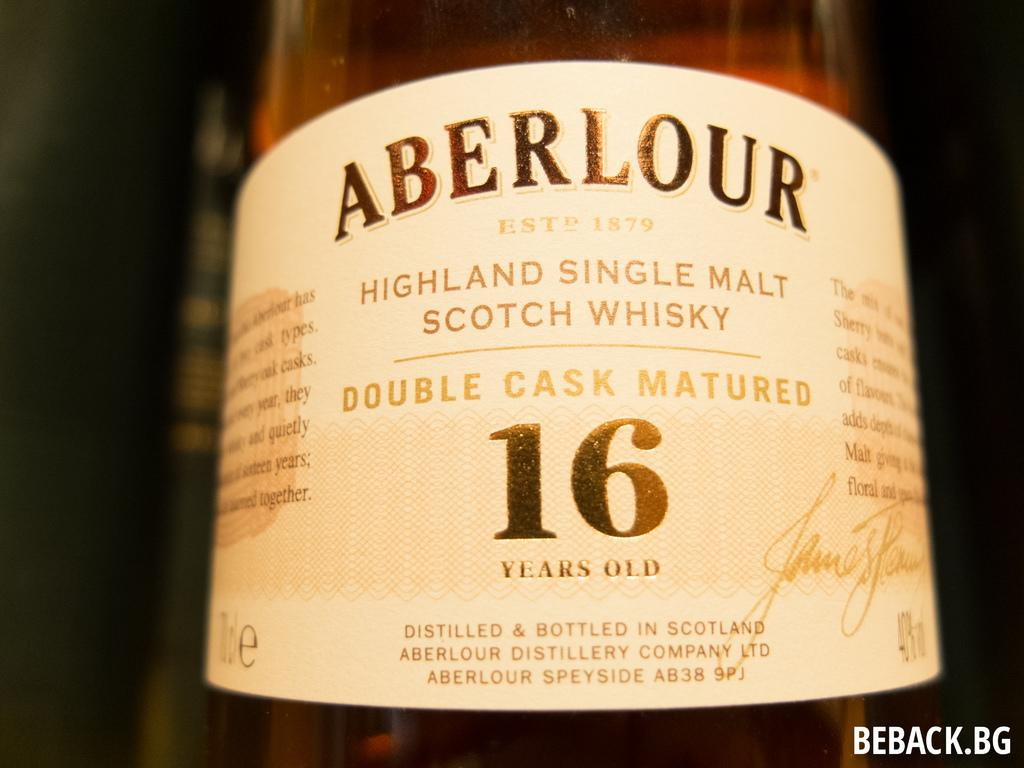<image>
Offer a succinct explanation of the picture presented. A bottle of Scotch whisky which has apparently been aged for sixteen years. 